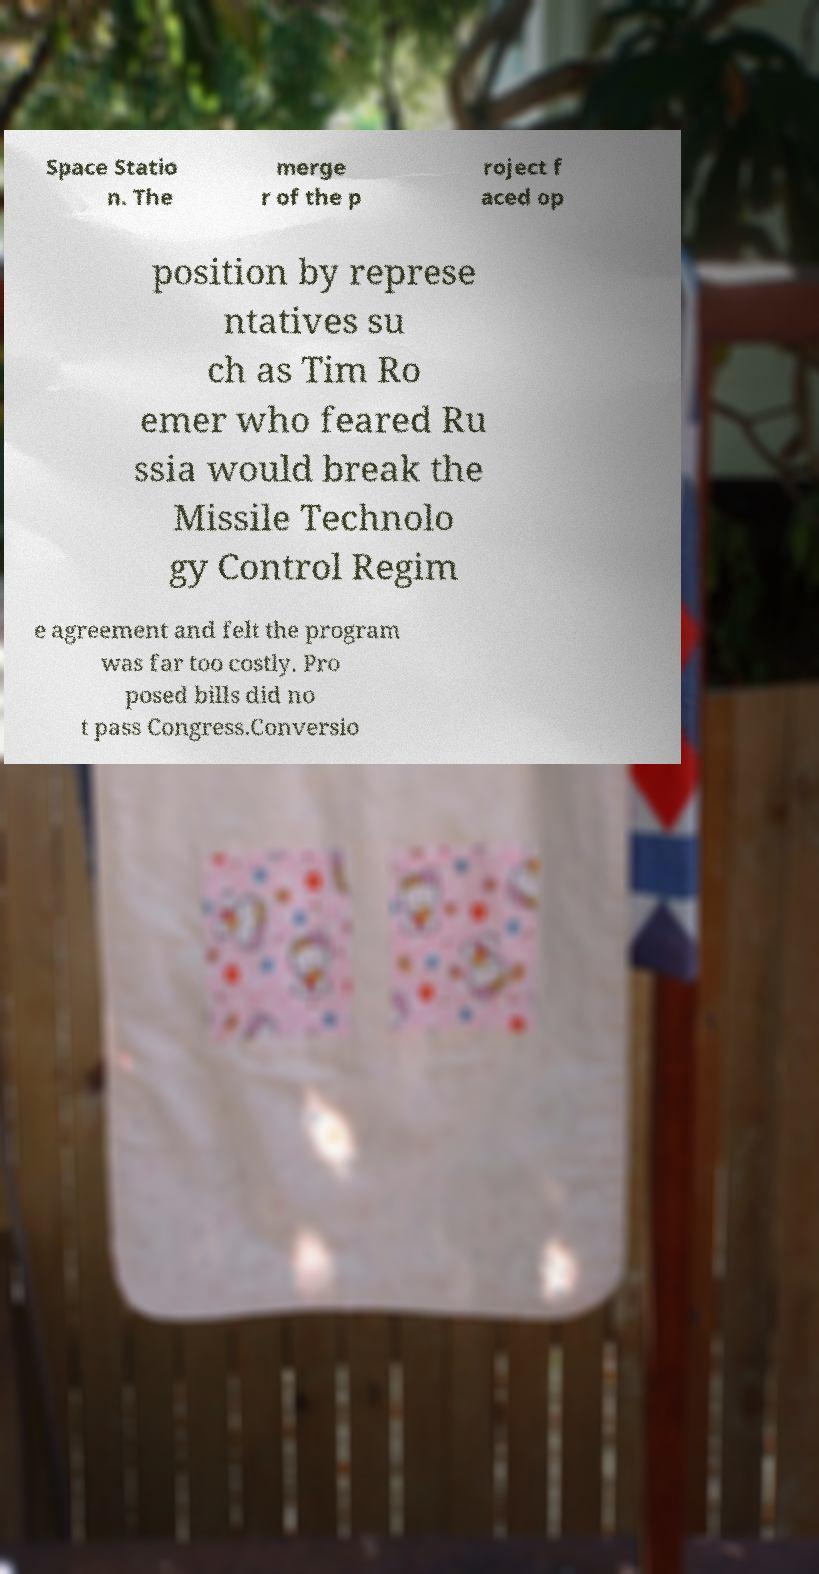Could you extract and type out the text from this image? Space Statio n. The merge r of the p roject f aced op position by represe ntatives su ch as Tim Ro emer who feared Ru ssia would break the Missile Technolo gy Control Regim e agreement and felt the program was far too costly. Pro posed bills did no t pass Congress.Conversio 